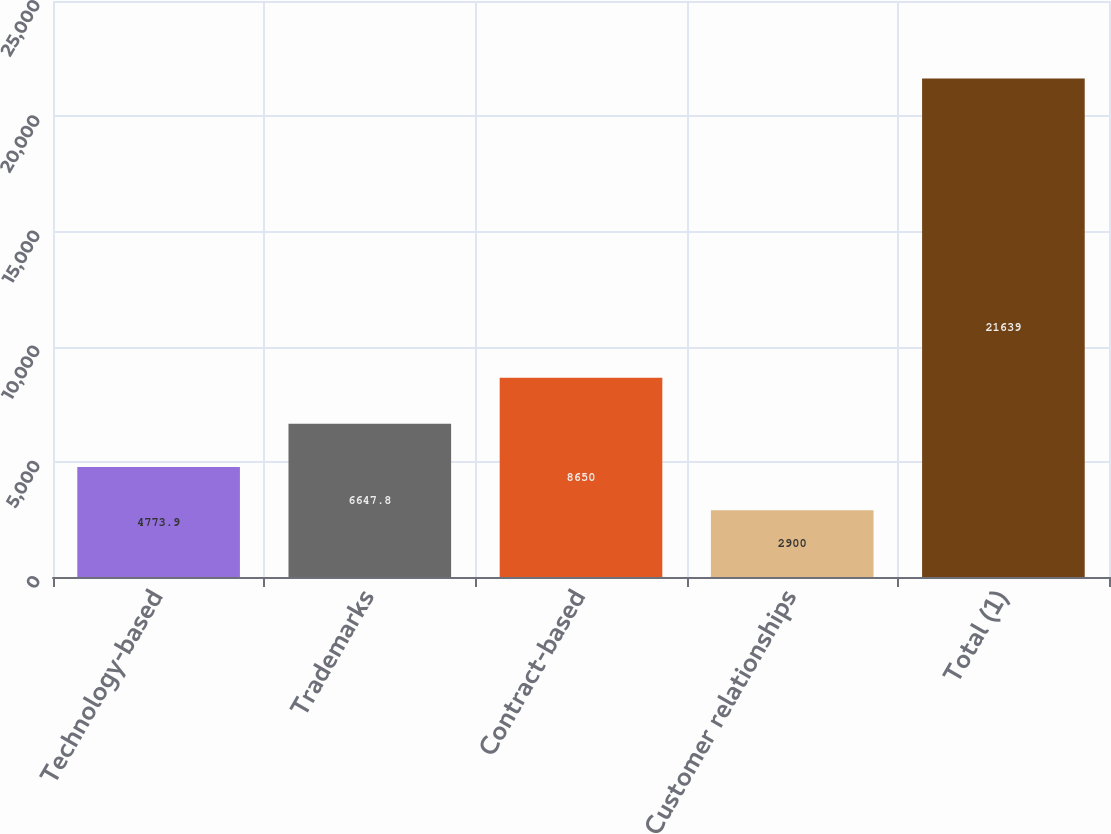Convert chart. <chart><loc_0><loc_0><loc_500><loc_500><bar_chart><fcel>Technology-based<fcel>Trademarks<fcel>Contract-based<fcel>Customer relationships<fcel>Total (1)<nl><fcel>4773.9<fcel>6647.8<fcel>8650<fcel>2900<fcel>21639<nl></chart> 